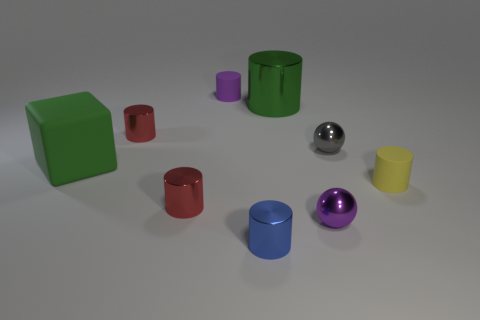Subtract all green cylinders. How many cylinders are left? 5 Subtract 2 cylinders. How many cylinders are left? 4 Subtract all green cylinders. How many cylinders are left? 5 Subtract all brown cylinders. Subtract all brown spheres. How many cylinders are left? 6 Add 1 large green spheres. How many objects exist? 10 Subtract all blocks. How many objects are left? 8 Subtract all blue shiny cylinders. Subtract all purple objects. How many objects are left? 6 Add 3 small blue cylinders. How many small blue cylinders are left? 4 Add 5 large rubber blocks. How many large rubber blocks exist? 6 Subtract 1 gray spheres. How many objects are left? 8 